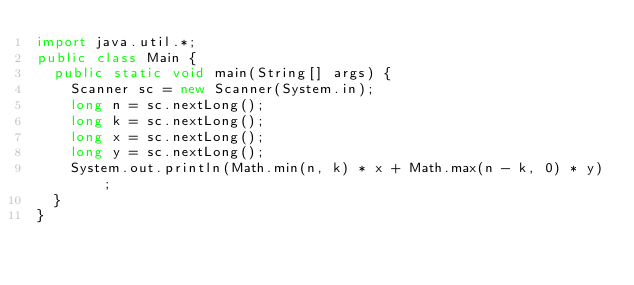<code> <loc_0><loc_0><loc_500><loc_500><_Java_>import java.util.*;
public class Main {
	public static void main(String[] args) {
		Scanner sc = new Scanner(System.in);
		long n = sc.nextLong();
		long k = sc.nextLong();
		long x = sc.nextLong();
		long y = sc.nextLong();
		System.out.println(Math.min(n, k) * x + Math.max(n - k, 0) * y);
	}
}</code> 